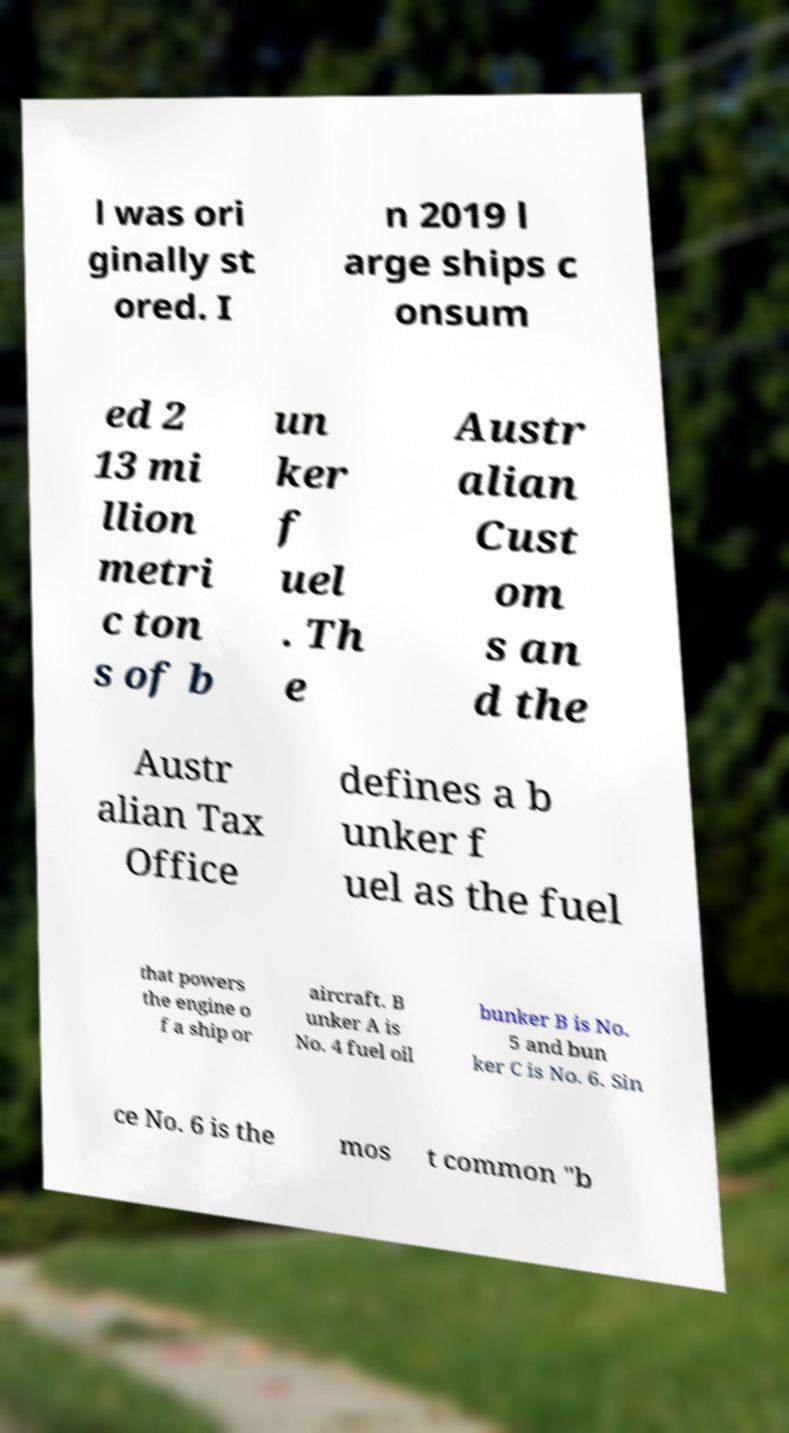I need the written content from this picture converted into text. Can you do that? l was ori ginally st ored. I n 2019 l arge ships c onsum ed 2 13 mi llion metri c ton s of b un ker f uel . Th e Austr alian Cust om s an d the Austr alian Tax Office defines a b unker f uel as the fuel that powers the engine o f a ship or aircraft. B unker A is No. 4 fuel oil bunker B is No. 5 and bun ker C is No. 6. Sin ce No. 6 is the mos t common "b 